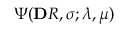<formula> <loc_0><loc_0><loc_500><loc_500>\Psi ( \mathbf R , \pm b \sigma ; \lambda , \mu )</formula> 